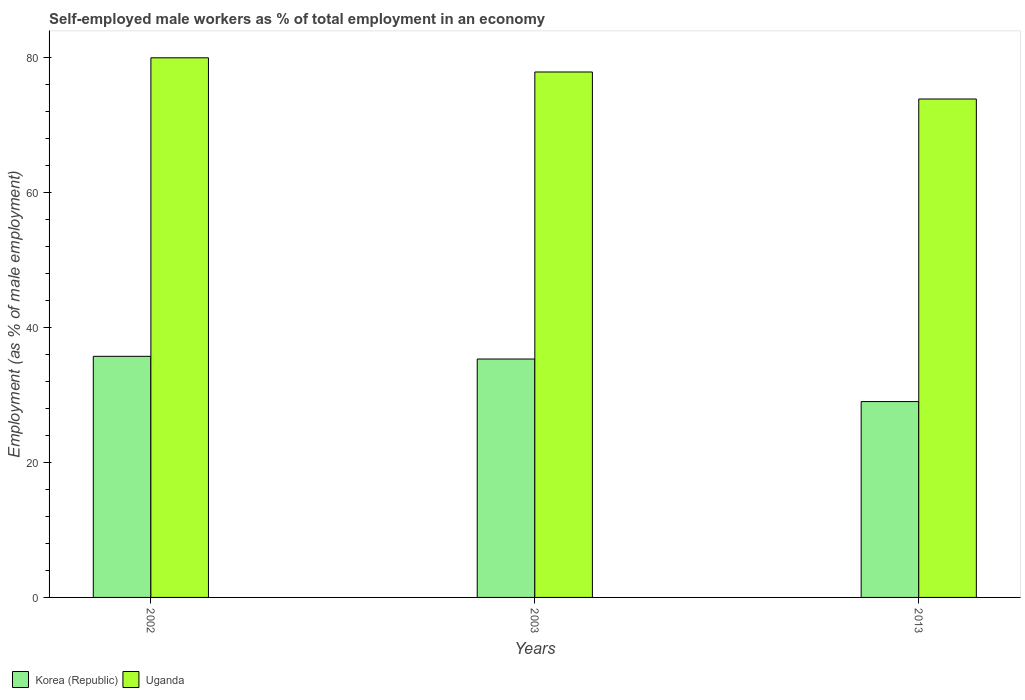Are the number of bars per tick equal to the number of legend labels?
Offer a terse response. Yes. Are the number of bars on each tick of the X-axis equal?
Your response must be concise. Yes. How many bars are there on the 3rd tick from the right?
Give a very brief answer. 2. What is the label of the 1st group of bars from the left?
Give a very brief answer. 2002. What is the percentage of self-employed male workers in Uganda in 2003?
Keep it short and to the point. 77.8. Across all years, what is the maximum percentage of self-employed male workers in Uganda?
Offer a terse response. 79.9. In which year was the percentage of self-employed male workers in Korea (Republic) minimum?
Your response must be concise. 2013. What is the total percentage of self-employed male workers in Korea (Republic) in the graph?
Offer a terse response. 100. What is the difference between the percentage of self-employed male workers in Korea (Republic) in 2002 and that in 2003?
Make the answer very short. 0.4. What is the difference between the percentage of self-employed male workers in Uganda in 2002 and the percentage of self-employed male workers in Korea (Republic) in 2013?
Your response must be concise. 50.9. What is the average percentage of self-employed male workers in Uganda per year?
Offer a terse response. 77.17. In the year 2013, what is the difference between the percentage of self-employed male workers in Korea (Republic) and percentage of self-employed male workers in Uganda?
Your answer should be compact. -44.8. In how many years, is the percentage of self-employed male workers in Uganda greater than 20 %?
Provide a short and direct response. 3. What is the ratio of the percentage of self-employed male workers in Uganda in 2003 to that in 2013?
Keep it short and to the point. 1.05. What is the difference between the highest and the second highest percentage of self-employed male workers in Korea (Republic)?
Ensure brevity in your answer.  0.4. What is the difference between the highest and the lowest percentage of self-employed male workers in Uganda?
Ensure brevity in your answer.  6.1. Is the sum of the percentage of self-employed male workers in Uganda in 2002 and 2003 greater than the maximum percentage of self-employed male workers in Korea (Republic) across all years?
Ensure brevity in your answer.  Yes. What does the 2nd bar from the left in 2013 represents?
Provide a short and direct response. Uganda. What does the 1st bar from the right in 2003 represents?
Provide a succinct answer. Uganda. How many bars are there?
Offer a terse response. 6. How many years are there in the graph?
Keep it short and to the point. 3. Are the values on the major ticks of Y-axis written in scientific E-notation?
Keep it short and to the point. No. How many legend labels are there?
Make the answer very short. 2. What is the title of the graph?
Offer a very short reply. Self-employed male workers as % of total employment in an economy. Does "China" appear as one of the legend labels in the graph?
Keep it short and to the point. No. What is the label or title of the Y-axis?
Keep it short and to the point. Employment (as % of male employment). What is the Employment (as % of male employment) of Korea (Republic) in 2002?
Offer a terse response. 35.7. What is the Employment (as % of male employment) of Uganda in 2002?
Provide a short and direct response. 79.9. What is the Employment (as % of male employment) of Korea (Republic) in 2003?
Your answer should be compact. 35.3. What is the Employment (as % of male employment) of Uganda in 2003?
Offer a very short reply. 77.8. What is the Employment (as % of male employment) in Uganda in 2013?
Your answer should be very brief. 73.8. Across all years, what is the maximum Employment (as % of male employment) of Korea (Republic)?
Offer a very short reply. 35.7. Across all years, what is the maximum Employment (as % of male employment) in Uganda?
Your answer should be very brief. 79.9. Across all years, what is the minimum Employment (as % of male employment) of Uganda?
Keep it short and to the point. 73.8. What is the total Employment (as % of male employment) of Korea (Republic) in the graph?
Give a very brief answer. 100. What is the total Employment (as % of male employment) of Uganda in the graph?
Ensure brevity in your answer.  231.5. What is the difference between the Employment (as % of male employment) in Uganda in 2002 and that in 2003?
Give a very brief answer. 2.1. What is the difference between the Employment (as % of male employment) of Uganda in 2002 and that in 2013?
Provide a short and direct response. 6.1. What is the difference between the Employment (as % of male employment) of Korea (Republic) in 2003 and that in 2013?
Make the answer very short. 6.3. What is the difference between the Employment (as % of male employment) in Uganda in 2003 and that in 2013?
Keep it short and to the point. 4. What is the difference between the Employment (as % of male employment) in Korea (Republic) in 2002 and the Employment (as % of male employment) in Uganda in 2003?
Your answer should be compact. -42.1. What is the difference between the Employment (as % of male employment) of Korea (Republic) in 2002 and the Employment (as % of male employment) of Uganda in 2013?
Provide a short and direct response. -38.1. What is the difference between the Employment (as % of male employment) in Korea (Republic) in 2003 and the Employment (as % of male employment) in Uganda in 2013?
Make the answer very short. -38.5. What is the average Employment (as % of male employment) in Korea (Republic) per year?
Your response must be concise. 33.33. What is the average Employment (as % of male employment) of Uganda per year?
Your answer should be compact. 77.17. In the year 2002, what is the difference between the Employment (as % of male employment) in Korea (Republic) and Employment (as % of male employment) in Uganda?
Your response must be concise. -44.2. In the year 2003, what is the difference between the Employment (as % of male employment) in Korea (Republic) and Employment (as % of male employment) in Uganda?
Keep it short and to the point. -42.5. In the year 2013, what is the difference between the Employment (as % of male employment) in Korea (Republic) and Employment (as % of male employment) in Uganda?
Keep it short and to the point. -44.8. What is the ratio of the Employment (as % of male employment) of Korea (Republic) in 2002 to that in 2003?
Your answer should be compact. 1.01. What is the ratio of the Employment (as % of male employment) of Uganda in 2002 to that in 2003?
Your answer should be very brief. 1.03. What is the ratio of the Employment (as % of male employment) of Korea (Republic) in 2002 to that in 2013?
Provide a short and direct response. 1.23. What is the ratio of the Employment (as % of male employment) in Uganda in 2002 to that in 2013?
Provide a succinct answer. 1.08. What is the ratio of the Employment (as % of male employment) in Korea (Republic) in 2003 to that in 2013?
Ensure brevity in your answer.  1.22. What is the ratio of the Employment (as % of male employment) of Uganda in 2003 to that in 2013?
Provide a short and direct response. 1.05. What is the difference between the highest and the second highest Employment (as % of male employment) in Korea (Republic)?
Ensure brevity in your answer.  0.4. What is the difference between the highest and the lowest Employment (as % of male employment) in Korea (Republic)?
Offer a very short reply. 6.7. 